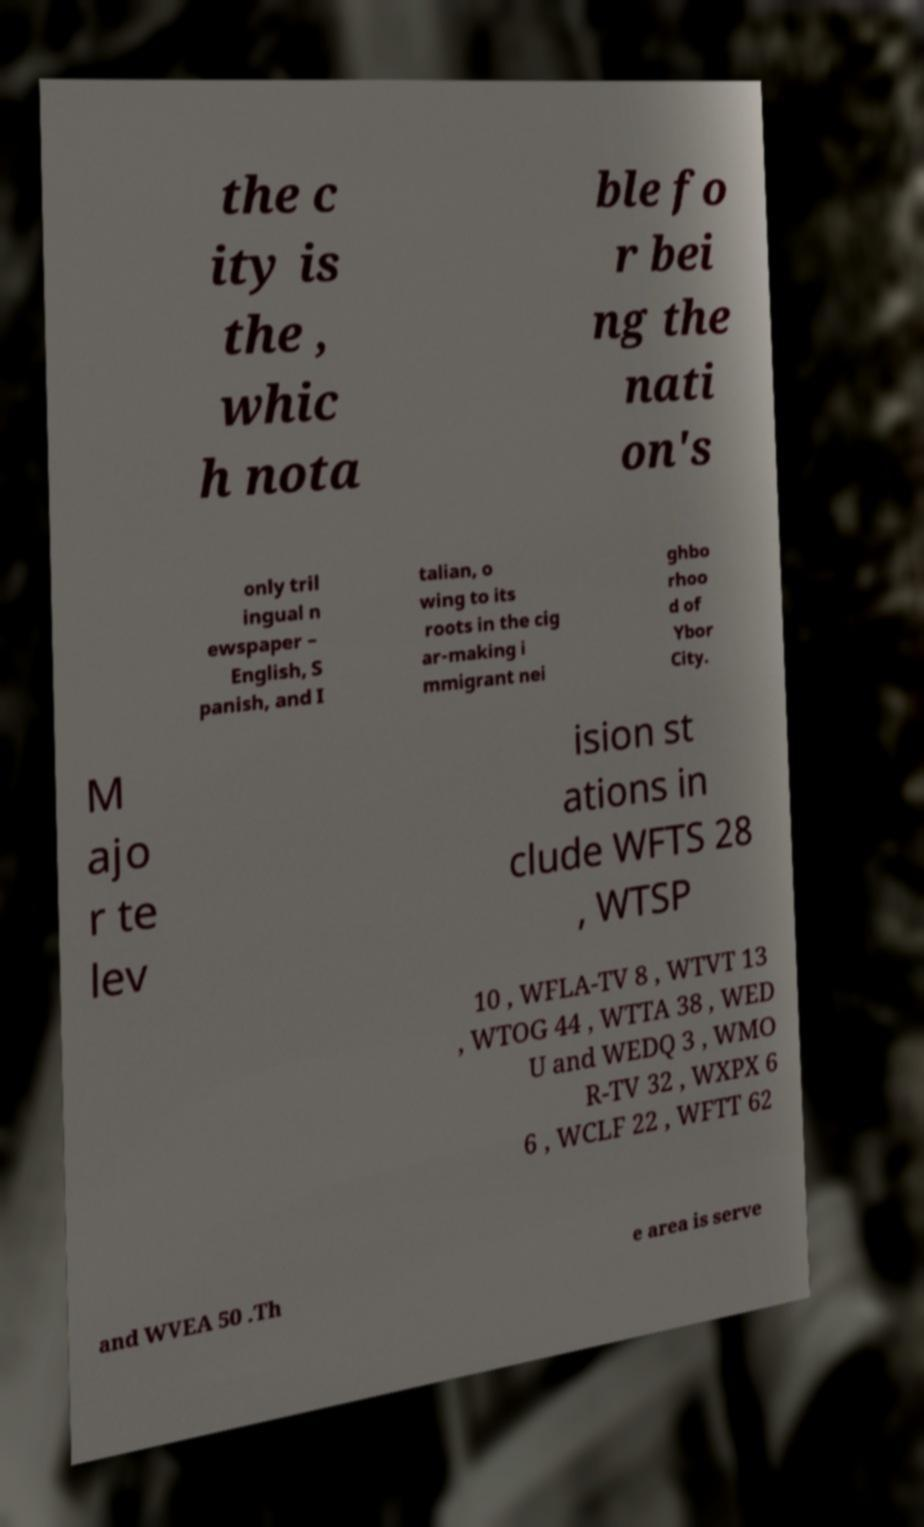For documentation purposes, I need the text within this image transcribed. Could you provide that? the c ity is the , whic h nota ble fo r bei ng the nati on's only tril ingual n ewspaper – English, S panish, and I talian, o wing to its roots in the cig ar-making i mmigrant nei ghbo rhoo d of Ybor City. M ajo r te lev ision st ations in clude WFTS 28 , WTSP 10 , WFLA-TV 8 , WTVT 13 , WTOG 44 , WTTA 38 , WED U and WEDQ 3 , WMO R-TV 32 , WXPX 6 6 , WCLF 22 , WFTT 62 and WVEA 50 .Th e area is serve 